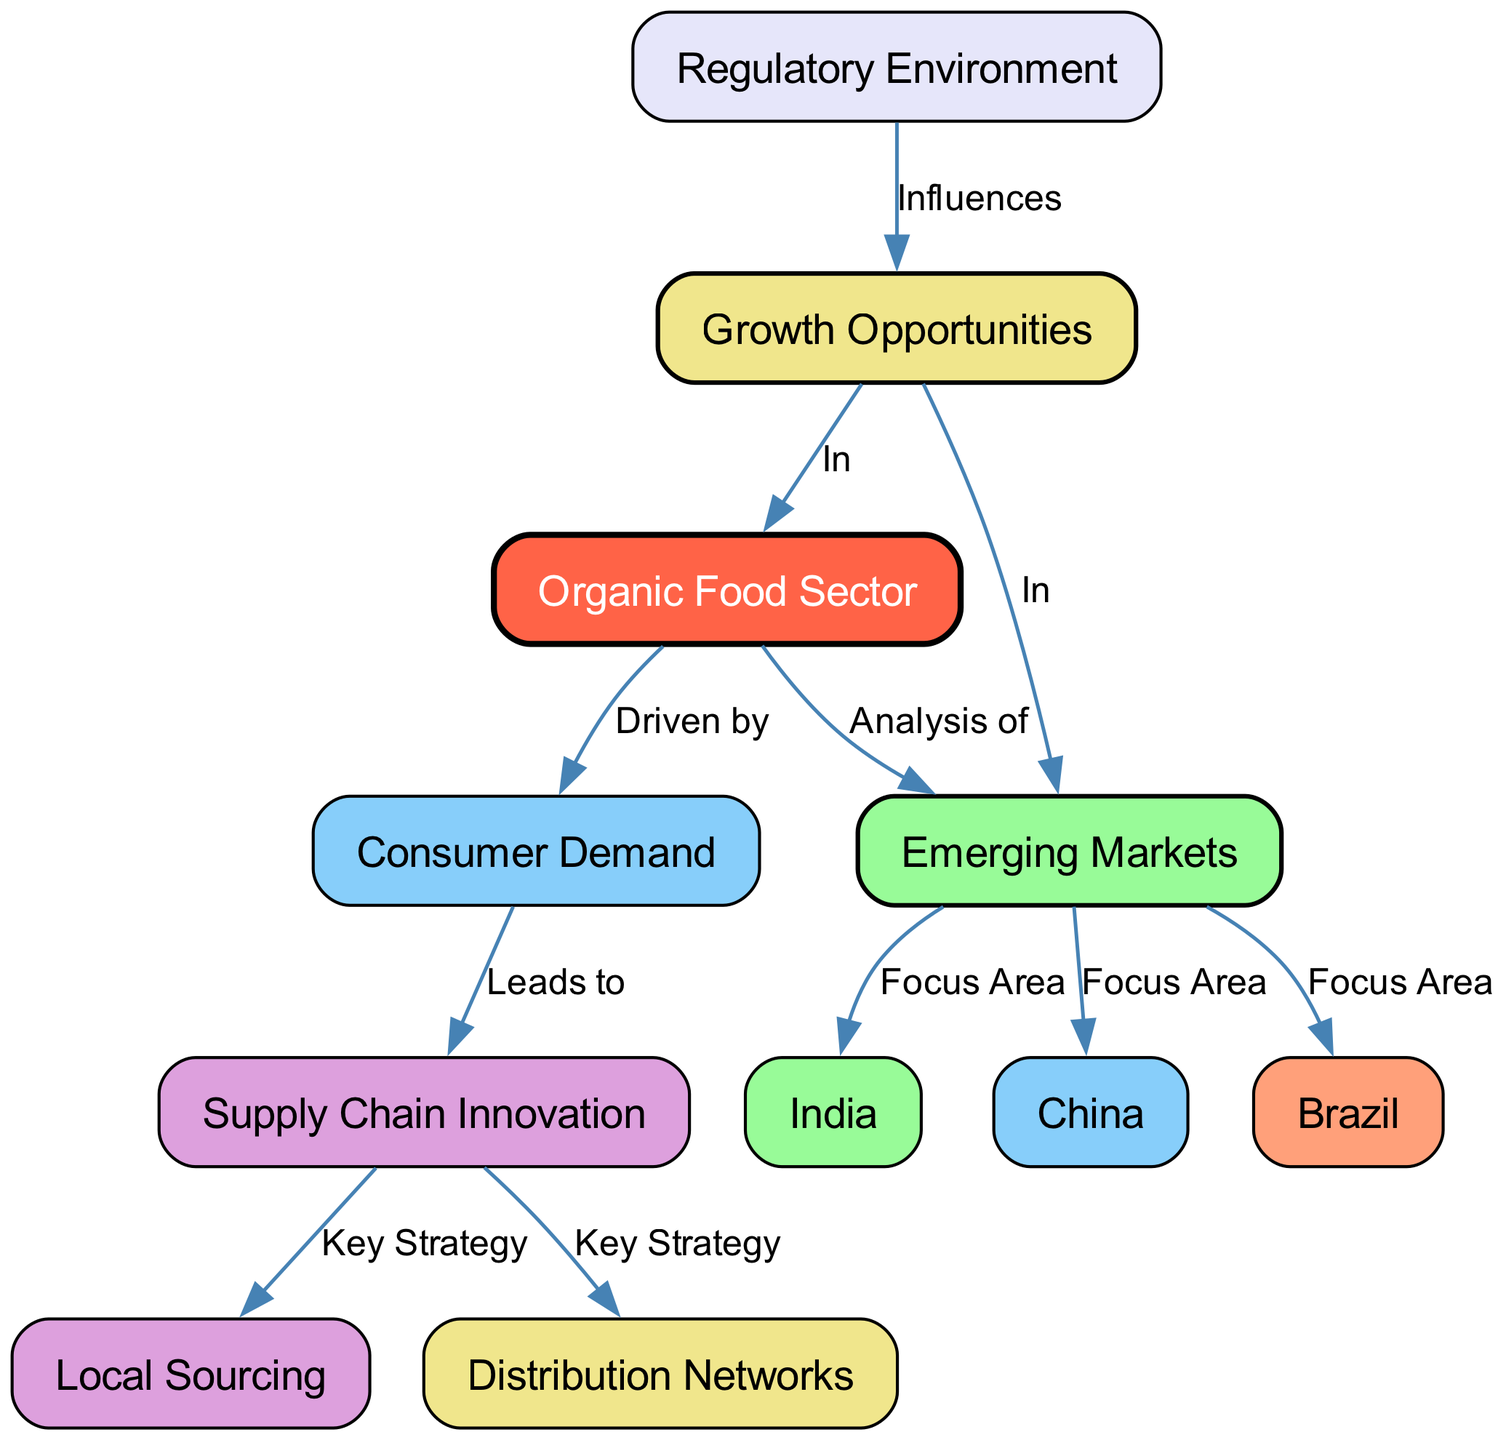What is the central node in this diagram? The central node is labeled "Organic Food Sector", which appears prominently in the center of the diagram and connects to various other nodes.
Answer: Organic Food Sector How many emerging markets are identified in the diagram? The diagram lists three emerging markets: Brazil, India, and China. Each is connected to the "Emerging Markets" node as a focus area.
Answer: Three Which node is connected to both "Supply Chain Innovation" and "Local Sourcing"? The "Supply Chain Innovation" node leads to two nodes: "Local Sourcing" and "Distribution Networks". Therefore, "Local Sourcing" connects to "Supply Chain Innovation".
Answer: Local Sourcing What influences the growth opportunities in the organic food sector? The "Regulatory Environment" node points to the "Growth Opportunities" node, indicating it influences these opportunities within the organic food sector.
Answer: Regulatory Environment In which node does consumer demand lead to changes? The "Consumer Demand" node leads to the "Supply Chain Innovation" node, indicating that changes in consumer demand result in supply chain innovations.
Answer: Supply Chain Innovation What are the two key strategies influenced by supply chain innovation? "Local Sourcing" and "Distribution Networks" are two key strategies that arise from "Supply Chain Innovation", as indicated by the edges leading from the latter.
Answer: Local Sourcing and Distribution Networks Where do emerging markets focus, according to the diagram? The focus areas for emerging markets are Brazil, India, and China, as indicated by the connections from the "Emerging Markets" node to each of these countries.
Answer: Brazil, India, and China How does growth opportunity relate to the organic food sector? The "Growth Opportunities" node is connected to both the "Organic Food Sector" and "Emerging Markets", meaning growth opportunities are relevant in both contexts.
Answer: In Organic Food Sector and Emerging Markets 